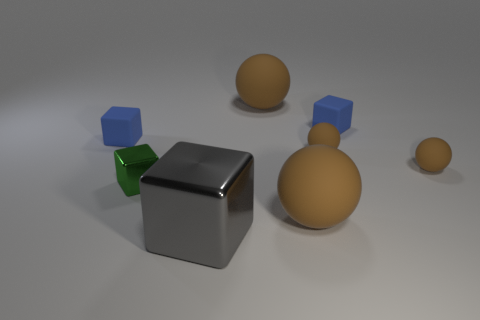Subtract all brown balls. How many were subtracted if there are1brown balls left? 3 Subtract all green metal cubes. How many cubes are left? 3 Add 1 blue things. How many objects exist? 9 Subtract all green blocks. How many blocks are left? 3 Subtract 0 red cylinders. How many objects are left? 8 Subtract 1 balls. How many balls are left? 3 Subtract all green spheres. Subtract all purple blocks. How many spheres are left? 4 Subtract all cyan balls. How many brown blocks are left? 0 Subtract all small brown objects. Subtract all small brown spheres. How many objects are left? 4 Add 5 gray blocks. How many gray blocks are left? 6 